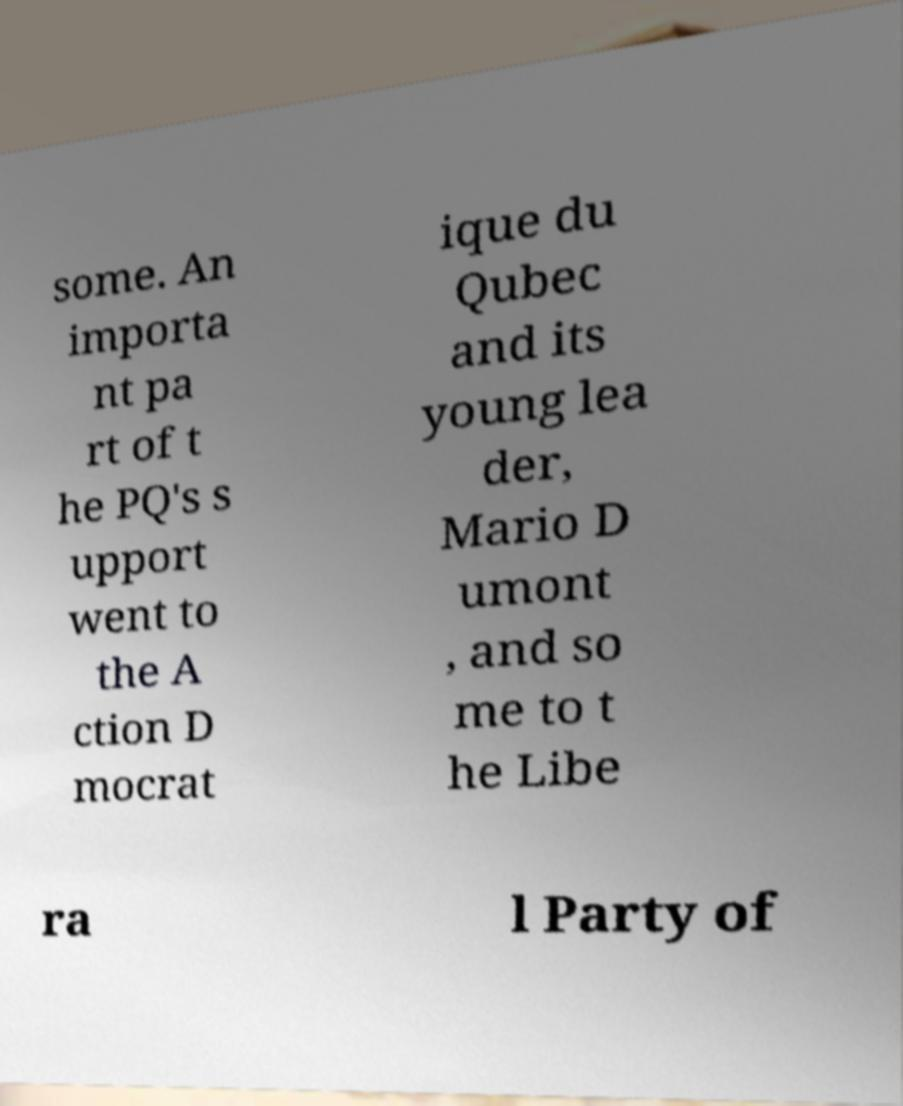I need the written content from this picture converted into text. Can you do that? some. An importa nt pa rt of t he PQ's s upport went to the A ction D mocrat ique du Qubec and its young lea der, Mario D umont , and so me to t he Libe ra l Party of 